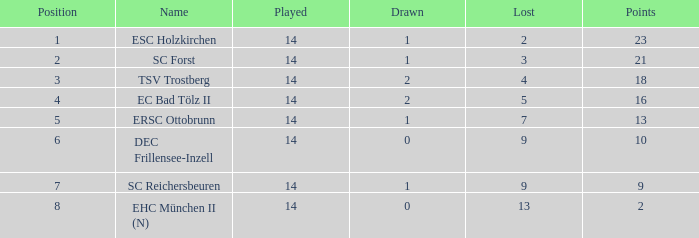How much Drawn has a Lost of 2, and Played smaller than 14? None. 